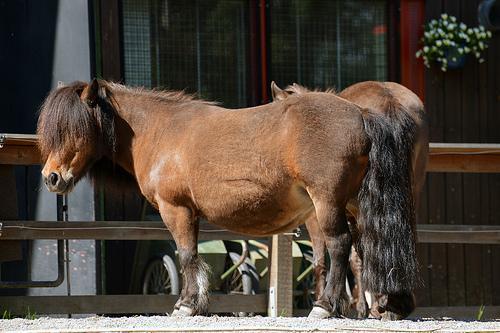How many horses are in the picture?
Give a very brief answer. 2. 